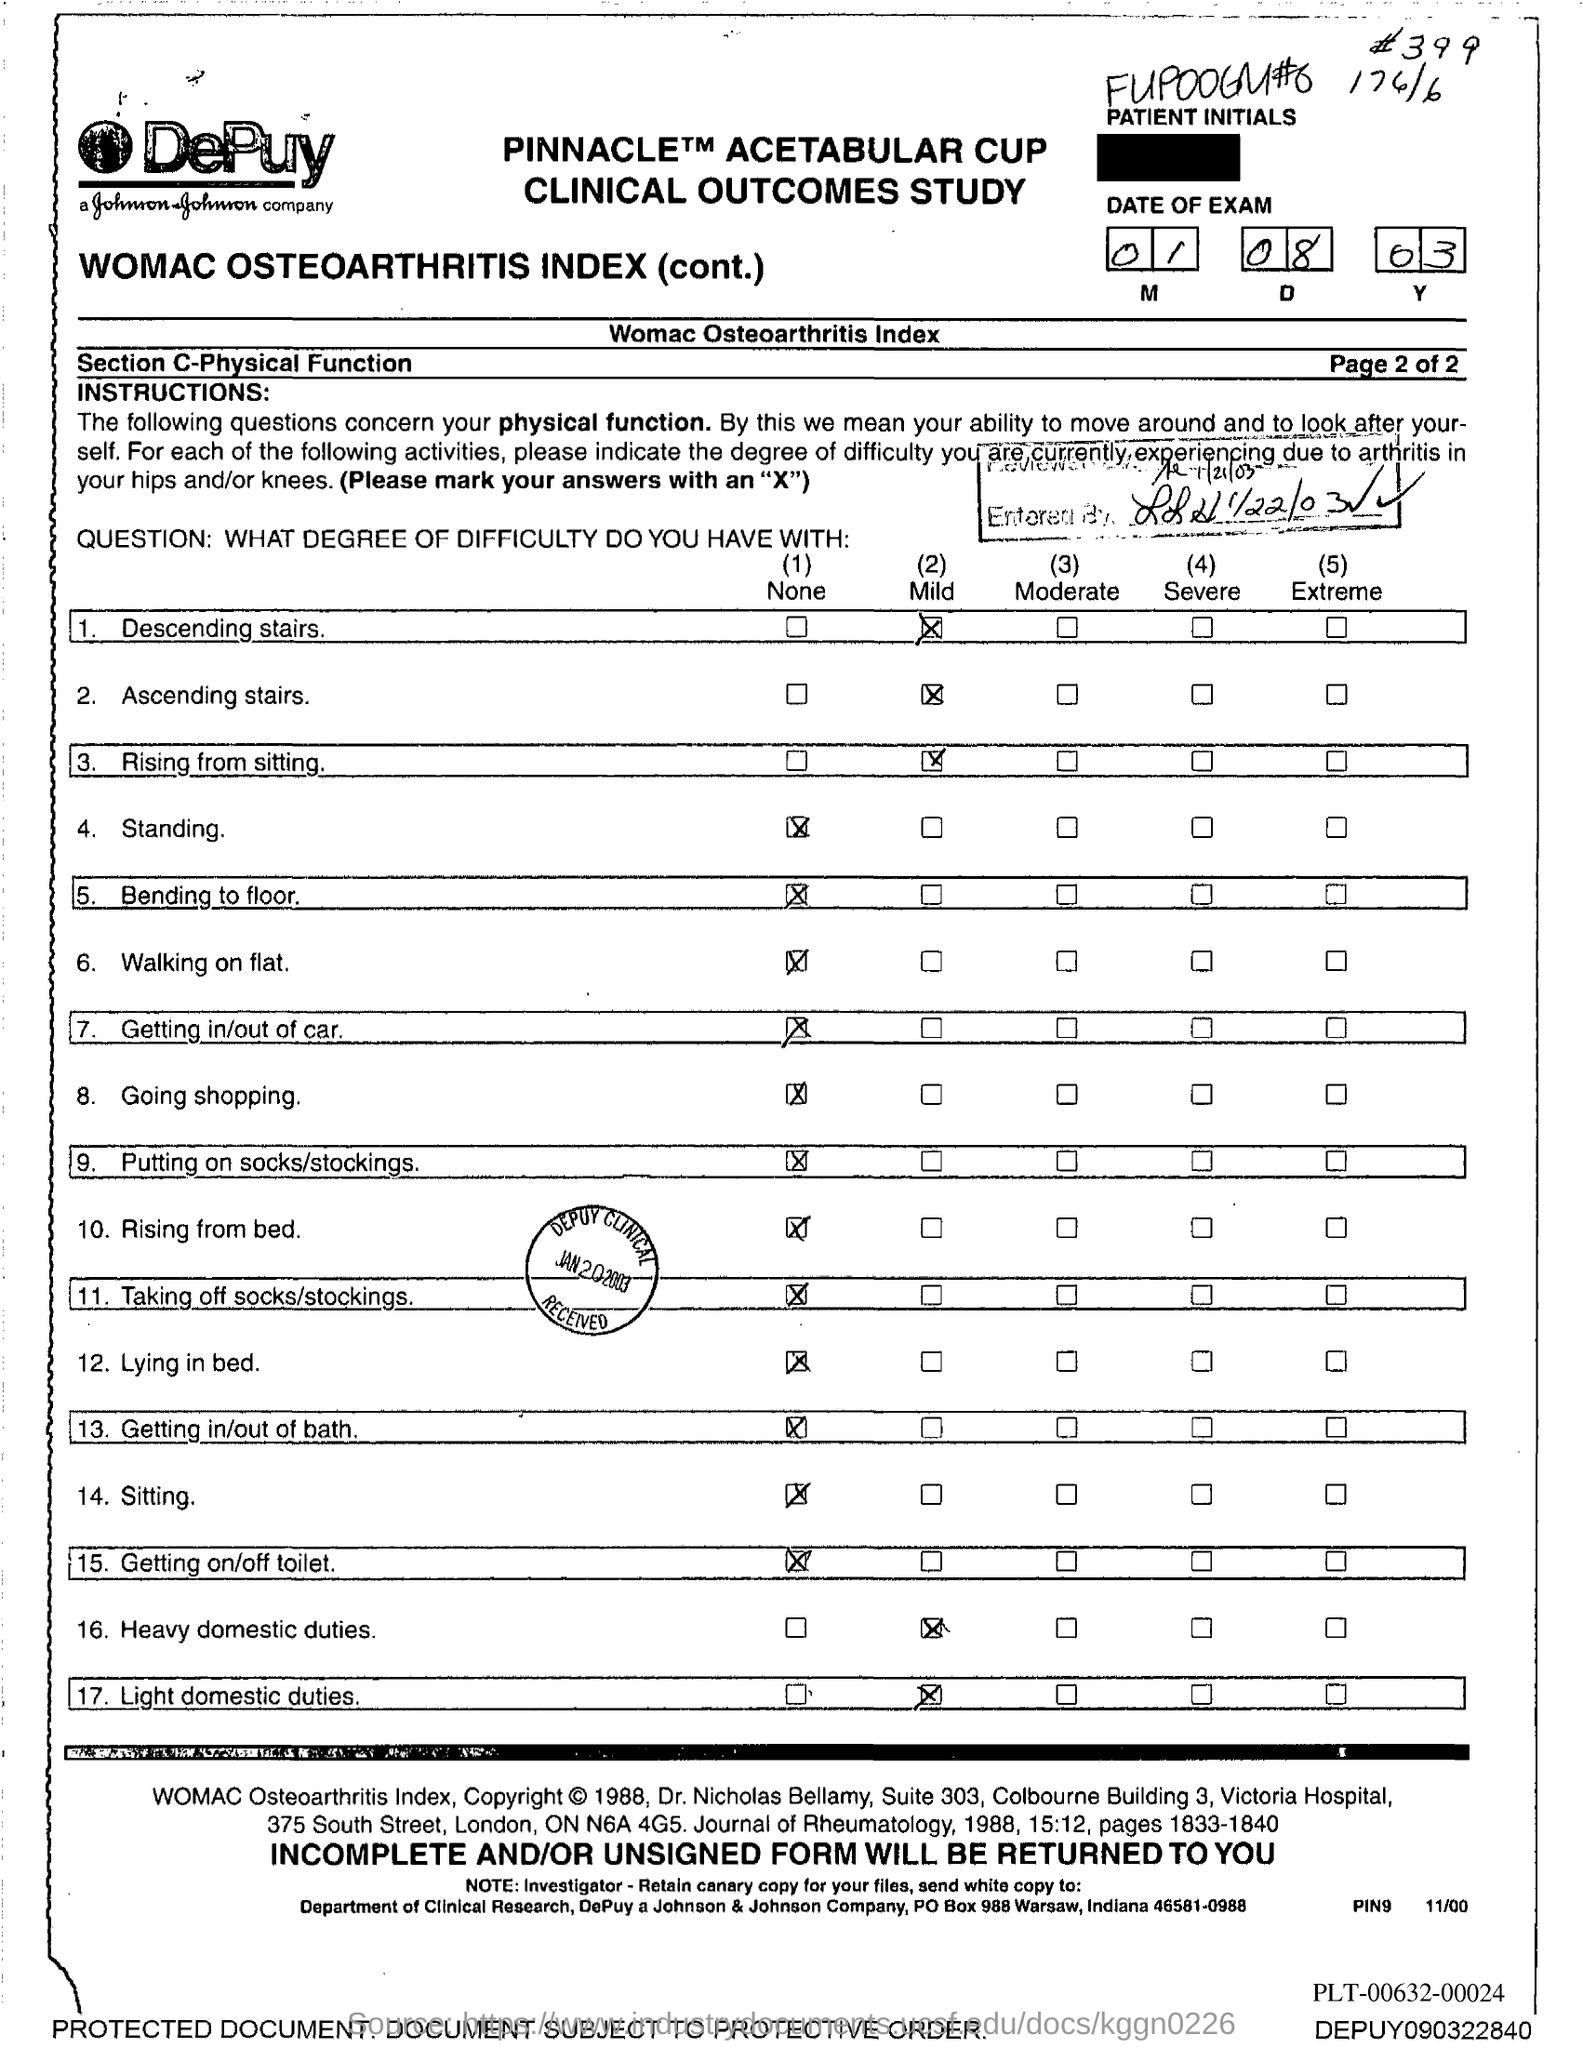Draw attention to some important aspects in this diagram. The month of the exam mentioned in the document is January. 